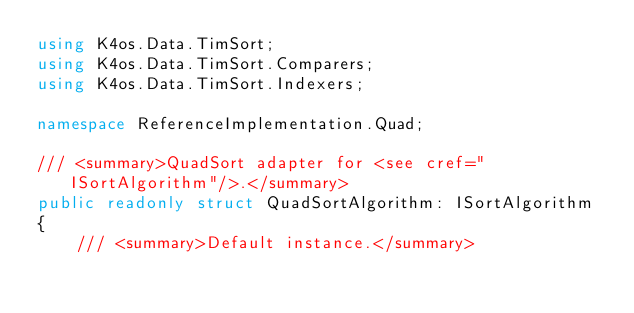Convert code to text. <code><loc_0><loc_0><loc_500><loc_500><_C#_>using K4os.Data.TimSort;
using K4os.Data.TimSort.Comparers;
using K4os.Data.TimSort.Indexers;

namespace ReferenceImplementation.Quad;

/// <summary>QuadSort adapter for <see cref="ISortAlgorithm"/>.</summary>
public readonly struct QuadSortAlgorithm: ISortAlgorithm
{
	/// <summary>Default instance.</summary></code> 